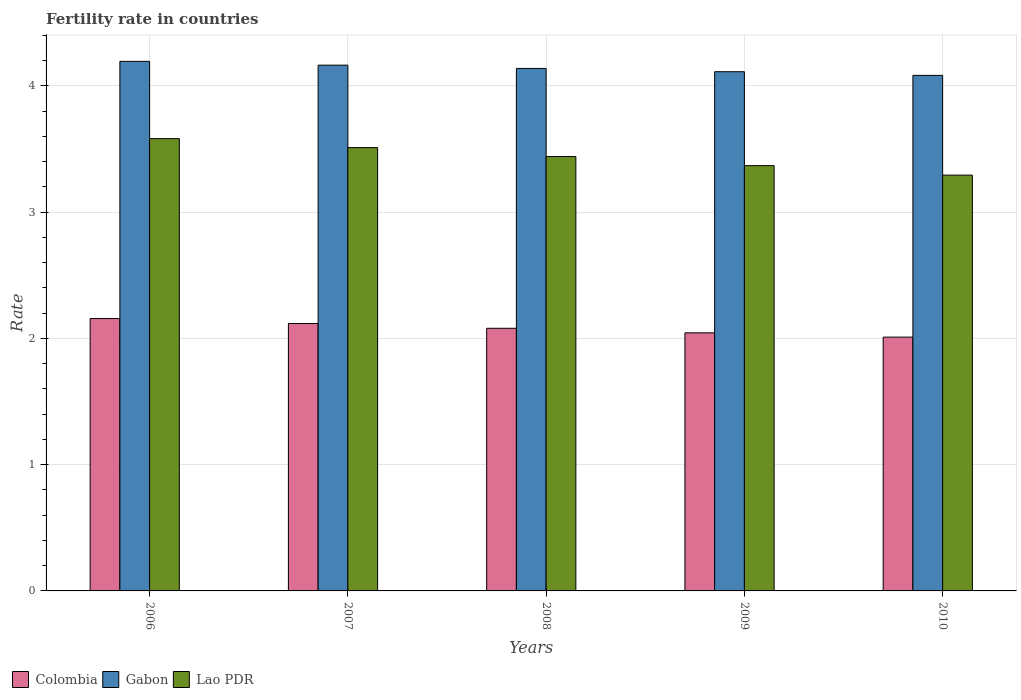How many different coloured bars are there?
Ensure brevity in your answer.  3. Are the number of bars per tick equal to the number of legend labels?
Your answer should be compact. Yes. How many bars are there on the 1st tick from the right?
Your answer should be compact. 3. What is the label of the 2nd group of bars from the left?
Offer a terse response. 2007. In how many cases, is the number of bars for a given year not equal to the number of legend labels?
Provide a succinct answer. 0. What is the fertility rate in Gabon in 2006?
Your answer should be very brief. 4.19. Across all years, what is the maximum fertility rate in Colombia?
Provide a short and direct response. 2.16. Across all years, what is the minimum fertility rate in Colombia?
Give a very brief answer. 2.01. In which year was the fertility rate in Colombia minimum?
Your answer should be compact. 2010. What is the total fertility rate in Lao PDR in the graph?
Provide a short and direct response. 17.19. What is the difference between the fertility rate in Colombia in 2006 and that in 2009?
Your answer should be compact. 0.11. What is the difference between the fertility rate in Gabon in 2008 and the fertility rate in Colombia in 2010?
Your response must be concise. 2.13. What is the average fertility rate in Colombia per year?
Your answer should be compact. 2.08. In the year 2010, what is the difference between the fertility rate in Lao PDR and fertility rate in Colombia?
Offer a very short reply. 1.28. What is the ratio of the fertility rate in Lao PDR in 2006 to that in 2009?
Give a very brief answer. 1.06. Is the fertility rate in Lao PDR in 2006 less than that in 2009?
Your answer should be compact. No. Is the difference between the fertility rate in Lao PDR in 2007 and 2009 greater than the difference between the fertility rate in Colombia in 2007 and 2009?
Offer a very short reply. Yes. What is the difference between the highest and the second highest fertility rate in Colombia?
Make the answer very short. 0.04. What is the difference between the highest and the lowest fertility rate in Lao PDR?
Your response must be concise. 0.29. Is the sum of the fertility rate in Colombia in 2006 and 2010 greater than the maximum fertility rate in Gabon across all years?
Offer a very short reply. No. What does the 3rd bar from the left in 2007 represents?
Give a very brief answer. Lao PDR. What does the 1st bar from the right in 2009 represents?
Provide a short and direct response. Lao PDR. Are all the bars in the graph horizontal?
Keep it short and to the point. No. How many years are there in the graph?
Make the answer very short. 5. Does the graph contain grids?
Offer a terse response. Yes. Where does the legend appear in the graph?
Offer a very short reply. Bottom left. How many legend labels are there?
Give a very brief answer. 3. How are the legend labels stacked?
Ensure brevity in your answer.  Horizontal. What is the title of the graph?
Provide a short and direct response. Fertility rate in countries. Does "Puerto Rico" appear as one of the legend labels in the graph?
Offer a terse response. No. What is the label or title of the Y-axis?
Your response must be concise. Rate. What is the Rate in Colombia in 2006?
Your answer should be compact. 2.16. What is the Rate of Gabon in 2006?
Provide a succinct answer. 4.19. What is the Rate in Lao PDR in 2006?
Your answer should be very brief. 3.58. What is the Rate of Colombia in 2007?
Ensure brevity in your answer.  2.12. What is the Rate of Gabon in 2007?
Your answer should be very brief. 4.16. What is the Rate in Lao PDR in 2007?
Keep it short and to the point. 3.51. What is the Rate of Colombia in 2008?
Your answer should be very brief. 2.08. What is the Rate in Gabon in 2008?
Provide a succinct answer. 4.14. What is the Rate in Lao PDR in 2008?
Keep it short and to the point. 3.44. What is the Rate in Colombia in 2009?
Give a very brief answer. 2.04. What is the Rate in Gabon in 2009?
Ensure brevity in your answer.  4.11. What is the Rate in Lao PDR in 2009?
Your answer should be very brief. 3.37. What is the Rate of Colombia in 2010?
Offer a very short reply. 2.01. What is the Rate of Gabon in 2010?
Your answer should be very brief. 4.08. What is the Rate in Lao PDR in 2010?
Provide a short and direct response. 3.29. Across all years, what is the maximum Rate of Colombia?
Make the answer very short. 2.16. Across all years, what is the maximum Rate in Gabon?
Make the answer very short. 4.19. Across all years, what is the maximum Rate of Lao PDR?
Ensure brevity in your answer.  3.58. Across all years, what is the minimum Rate in Colombia?
Provide a short and direct response. 2.01. Across all years, what is the minimum Rate of Gabon?
Ensure brevity in your answer.  4.08. Across all years, what is the minimum Rate of Lao PDR?
Ensure brevity in your answer.  3.29. What is the total Rate in Colombia in the graph?
Keep it short and to the point. 10.41. What is the total Rate in Gabon in the graph?
Give a very brief answer. 20.69. What is the total Rate of Lao PDR in the graph?
Provide a short and direct response. 17.19. What is the difference between the Rate of Colombia in 2006 and that in 2007?
Offer a terse response. 0.04. What is the difference between the Rate in Lao PDR in 2006 and that in 2007?
Provide a short and direct response. 0.07. What is the difference between the Rate of Colombia in 2006 and that in 2008?
Ensure brevity in your answer.  0.08. What is the difference between the Rate of Gabon in 2006 and that in 2008?
Offer a very short reply. 0.06. What is the difference between the Rate in Lao PDR in 2006 and that in 2008?
Make the answer very short. 0.14. What is the difference between the Rate of Colombia in 2006 and that in 2009?
Your answer should be compact. 0.11. What is the difference between the Rate of Gabon in 2006 and that in 2009?
Ensure brevity in your answer.  0.08. What is the difference between the Rate of Lao PDR in 2006 and that in 2009?
Keep it short and to the point. 0.21. What is the difference between the Rate of Colombia in 2006 and that in 2010?
Give a very brief answer. 0.15. What is the difference between the Rate in Gabon in 2006 and that in 2010?
Give a very brief answer. 0.11. What is the difference between the Rate in Lao PDR in 2006 and that in 2010?
Provide a succinct answer. 0.29. What is the difference between the Rate of Colombia in 2007 and that in 2008?
Provide a short and direct response. 0.04. What is the difference between the Rate of Gabon in 2007 and that in 2008?
Ensure brevity in your answer.  0.03. What is the difference between the Rate of Lao PDR in 2007 and that in 2008?
Ensure brevity in your answer.  0.07. What is the difference between the Rate in Colombia in 2007 and that in 2009?
Your response must be concise. 0.07. What is the difference between the Rate in Gabon in 2007 and that in 2009?
Provide a succinct answer. 0.05. What is the difference between the Rate of Lao PDR in 2007 and that in 2009?
Your answer should be very brief. 0.14. What is the difference between the Rate of Colombia in 2007 and that in 2010?
Your response must be concise. 0.11. What is the difference between the Rate in Gabon in 2007 and that in 2010?
Offer a very short reply. 0.08. What is the difference between the Rate of Lao PDR in 2007 and that in 2010?
Provide a succinct answer. 0.22. What is the difference between the Rate in Colombia in 2008 and that in 2009?
Provide a short and direct response. 0.04. What is the difference between the Rate in Gabon in 2008 and that in 2009?
Your response must be concise. 0.03. What is the difference between the Rate in Lao PDR in 2008 and that in 2009?
Keep it short and to the point. 0.07. What is the difference between the Rate in Colombia in 2008 and that in 2010?
Your answer should be very brief. 0.07. What is the difference between the Rate of Gabon in 2008 and that in 2010?
Make the answer very short. 0.06. What is the difference between the Rate in Lao PDR in 2008 and that in 2010?
Provide a succinct answer. 0.15. What is the difference between the Rate in Colombia in 2009 and that in 2010?
Provide a short and direct response. 0.03. What is the difference between the Rate in Gabon in 2009 and that in 2010?
Offer a terse response. 0.03. What is the difference between the Rate of Lao PDR in 2009 and that in 2010?
Give a very brief answer. 0.07. What is the difference between the Rate of Colombia in 2006 and the Rate of Gabon in 2007?
Offer a very short reply. -2.01. What is the difference between the Rate of Colombia in 2006 and the Rate of Lao PDR in 2007?
Give a very brief answer. -1.35. What is the difference between the Rate in Gabon in 2006 and the Rate in Lao PDR in 2007?
Make the answer very short. 0.68. What is the difference between the Rate in Colombia in 2006 and the Rate in Gabon in 2008?
Ensure brevity in your answer.  -1.98. What is the difference between the Rate of Colombia in 2006 and the Rate of Lao PDR in 2008?
Your answer should be compact. -1.28. What is the difference between the Rate in Gabon in 2006 and the Rate in Lao PDR in 2008?
Offer a terse response. 0.75. What is the difference between the Rate of Colombia in 2006 and the Rate of Gabon in 2009?
Your response must be concise. -1.96. What is the difference between the Rate of Colombia in 2006 and the Rate of Lao PDR in 2009?
Provide a short and direct response. -1.21. What is the difference between the Rate of Gabon in 2006 and the Rate of Lao PDR in 2009?
Your answer should be compact. 0.83. What is the difference between the Rate in Colombia in 2006 and the Rate in Gabon in 2010?
Keep it short and to the point. -1.93. What is the difference between the Rate of Colombia in 2006 and the Rate of Lao PDR in 2010?
Give a very brief answer. -1.14. What is the difference between the Rate of Gabon in 2006 and the Rate of Lao PDR in 2010?
Your answer should be compact. 0.9. What is the difference between the Rate in Colombia in 2007 and the Rate in Gabon in 2008?
Provide a succinct answer. -2.02. What is the difference between the Rate of Colombia in 2007 and the Rate of Lao PDR in 2008?
Give a very brief answer. -1.32. What is the difference between the Rate of Gabon in 2007 and the Rate of Lao PDR in 2008?
Your response must be concise. 0.72. What is the difference between the Rate of Colombia in 2007 and the Rate of Gabon in 2009?
Ensure brevity in your answer.  -1.99. What is the difference between the Rate of Colombia in 2007 and the Rate of Lao PDR in 2009?
Provide a short and direct response. -1.25. What is the difference between the Rate in Gabon in 2007 and the Rate in Lao PDR in 2009?
Give a very brief answer. 0.8. What is the difference between the Rate in Colombia in 2007 and the Rate in Gabon in 2010?
Give a very brief answer. -1.97. What is the difference between the Rate of Colombia in 2007 and the Rate of Lao PDR in 2010?
Keep it short and to the point. -1.18. What is the difference between the Rate in Gabon in 2007 and the Rate in Lao PDR in 2010?
Provide a succinct answer. 0.87. What is the difference between the Rate in Colombia in 2008 and the Rate in Gabon in 2009?
Ensure brevity in your answer.  -2.03. What is the difference between the Rate of Colombia in 2008 and the Rate of Lao PDR in 2009?
Provide a succinct answer. -1.29. What is the difference between the Rate of Gabon in 2008 and the Rate of Lao PDR in 2009?
Make the answer very short. 0.77. What is the difference between the Rate in Colombia in 2008 and the Rate in Gabon in 2010?
Keep it short and to the point. -2. What is the difference between the Rate in Colombia in 2008 and the Rate in Lao PDR in 2010?
Offer a terse response. -1.21. What is the difference between the Rate of Gabon in 2008 and the Rate of Lao PDR in 2010?
Give a very brief answer. 0.84. What is the difference between the Rate in Colombia in 2009 and the Rate in Gabon in 2010?
Offer a very short reply. -2.04. What is the difference between the Rate in Colombia in 2009 and the Rate in Lao PDR in 2010?
Your answer should be very brief. -1.25. What is the difference between the Rate in Gabon in 2009 and the Rate in Lao PDR in 2010?
Give a very brief answer. 0.82. What is the average Rate in Colombia per year?
Your answer should be very brief. 2.08. What is the average Rate of Gabon per year?
Give a very brief answer. 4.14. What is the average Rate of Lao PDR per year?
Your answer should be compact. 3.44. In the year 2006, what is the difference between the Rate of Colombia and Rate of Gabon?
Offer a terse response. -2.04. In the year 2006, what is the difference between the Rate of Colombia and Rate of Lao PDR?
Your response must be concise. -1.43. In the year 2006, what is the difference between the Rate in Gabon and Rate in Lao PDR?
Offer a terse response. 0.61. In the year 2007, what is the difference between the Rate in Colombia and Rate in Gabon?
Provide a short and direct response. -2.05. In the year 2007, what is the difference between the Rate of Colombia and Rate of Lao PDR?
Ensure brevity in your answer.  -1.39. In the year 2007, what is the difference between the Rate of Gabon and Rate of Lao PDR?
Your answer should be compact. 0.65. In the year 2008, what is the difference between the Rate of Colombia and Rate of Gabon?
Your response must be concise. -2.06. In the year 2008, what is the difference between the Rate in Colombia and Rate in Lao PDR?
Your answer should be very brief. -1.36. In the year 2008, what is the difference between the Rate in Gabon and Rate in Lao PDR?
Provide a succinct answer. 0.7. In the year 2009, what is the difference between the Rate in Colombia and Rate in Gabon?
Provide a short and direct response. -2.07. In the year 2009, what is the difference between the Rate in Colombia and Rate in Lao PDR?
Your response must be concise. -1.32. In the year 2009, what is the difference between the Rate of Gabon and Rate of Lao PDR?
Provide a succinct answer. 0.74. In the year 2010, what is the difference between the Rate in Colombia and Rate in Gabon?
Your answer should be compact. -2.07. In the year 2010, what is the difference between the Rate in Colombia and Rate in Lao PDR?
Keep it short and to the point. -1.28. In the year 2010, what is the difference between the Rate of Gabon and Rate of Lao PDR?
Make the answer very short. 0.79. What is the ratio of the Rate of Colombia in 2006 to that in 2007?
Offer a very short reply. 1.02. What is the ratio of the Rate in Gabon in 2006 to that in 2007?
Provide a short and direct response. 1.01. What is the ratio of the Rate in Lao PDR in 2006 to that in 2007?
Your response must be concise. 1.02. What is the ratio of the Rate in Colombia in 2006 to that in 2008?
Give a very brief answer. 1.04. What is the ratio of the Rate of Gabon in 2006 to that in 2008?
Make the answer very short. 1.01. What is the ratio of the Rate in Lao PDR in 2006 to that in 2008?
Make the answer very short. 1.04. What is the ratio of the Rate in Colombia in 2006 to that in 2009?
Make the answer very short. 1.06. What is the ratio of the Rate in Gabon in 2006 to that in 2009?
Your response must be concise. 1.02. What is the ratio of the Rate of Lao PDR in 2006 to that in 2009?
Offer a terse response. 1.06. What is the ratio of the Rate in Colombia in 2006 to that in 2010?
Your answer should be very brief. 1.07. What is the ratio of the Rate of Gabon in 2006 to that in 2010?
Give a very brief answer. 1.03. What is the ratio of the Rate of Lao PDR in 2006 to that in 2010?
Ensure brevity in your answer.  1.09. What is the ratio of the Rate of Colombia in 2007 to that in 2008?
Your response must be concise. 1.02. What is the ratio of the Rate of Lao PDR in 2007 to that in 2008?
Your answer should be very brief. 1.02. What is the ratio of the Rate of Colombia in 2007 to that in 2009?
Your answer should be compact. 1.04. What is the ratio of the Rate of Gabon in 2007 to that in 2009?
Make the answer very short. 1.01. What is the ratio of the Rate of Lao PDR in 2007 to that in 2009?
Provide a short and direct response. 1.04. What is the ratio of the Rate in Colombia in 2007 to that in 2010?
Provide a short and direct response. 1.05. What is the ratio of the Rate in Gabon in 2007 to that in 2010?
Provide a short and direct response. 1.02. What is the ratio of the Rate in Lao PDR in 2007 to that in 2010?
Your response must be concise. 1.07. What is the ratio of the Rate of Colombia in 2008 to that in 2009?
Your answer should be very brief. 1.02. What is the ratio of the Rate of Gabon in 2008 to that in 2009?
Make the answer very short. 1.01. What is the ratio of the Rate in Lao PDR in 2008 to that in 2009?
Your answer should be very brief. 1.02. What is the ratio of the Rate of Colombia in 2008 to that in 2010?
Make the answer very short. 1.03. What is the ratio of the Rate of Gabon in 2008 to that in 2010?
Provide a succinct answer. 1.01. What is the ratio of the Rate in Lao PDR in 2008 to that in 2010?
Ensure brevity in your answer.  1.04. What is the ratio of the Rate in Colombia in 2009 to that in 2010?
Your answer should be compact. 1.02. What is the ratio of the Rate of Gabon in 2009 to that in 2010?
Keep it short and to the point. 1.01. What is the ratio of the Rate in Lao PDR in 2009 to that in 2010?
Ensure brevity in your answer.  1.02. What is the difference between the highest and the second highest Rate of Colombia?
Ensure brevity in your answer.  0.04. What is the difference between the highest and the second highest Rate of Gabon?
Your response must be concise. 0.03. What is the difference between the highest and the second highest Rate in Lao PDR?
Keep it short and to the point. 0.07. What is the difference between the highest and the lowest Rate of Colombia?
Keep it short and to the point. 0.15. What is the difference between the highest and the lowest Rate in Gabon?
Make the answer very short. 0.11. What is the difference between the highest and the lowest Rate of Lao PDR?
Your answer should be compact. 0.29. 